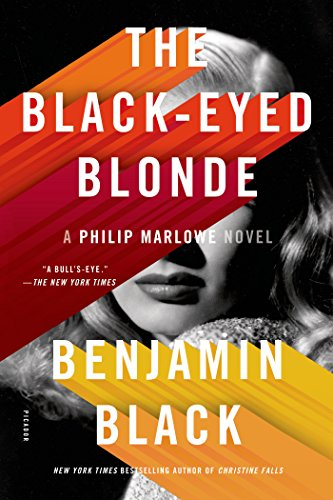What is the genre of this book? This novel falls solidly within the 'Mystery, Thriller & Suspense' genres, providing a riveting narrative that keeps readers on the edge of their seats with its complex plot twists and intense atmosphere. 